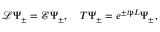Convert formula to latex. <formula><loc_0><loc_0><loc_500><loc_500>\begin{array} { r } { \mathcal { L } \Psi _ { \pm } = \mathcal { E } \Psi _ { \pm } , \quad T \Psi _ { \pm } = e ^ { \pm i \mathfrak { p } L } \Psi _ { \pm } , } \end{array}</formula> 